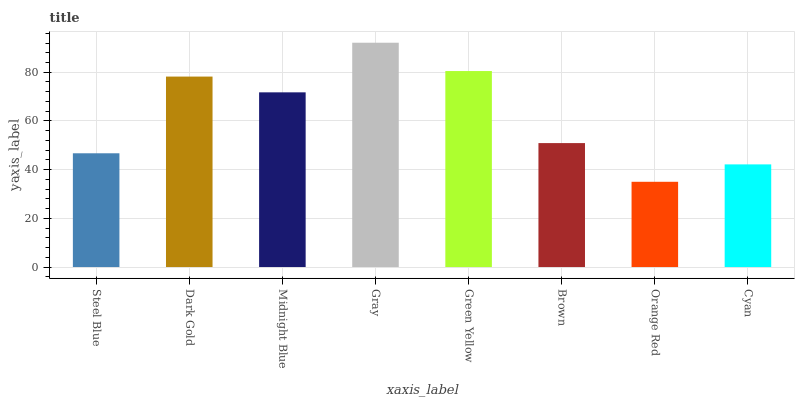Is Orange Red the minimum?
Answer yes or no. Yes. Is Gray the maximum?
Answer yes or no. Yes. Is Dark Gold the minimum?
Answer yes or no. No. Is Dark Gold the maximum?
Answer yes or no. No. Is Dark Gold greater than Steel Blue?
Answer yes or no. Yes. Is Steel Blue less than Dark Gold?
Answer yes or no. Yes. Is Steel Blue greater than Dark Gold?
Answer yes or no. No. Is Dark Gold less than Steel Blue?
Answer yes or no. No. Is Midnight Blue the high median?
Answer yes or no. Yes. Is Brown the low median?
Answer yes or no. Yes. Is Orange Red the high median?
Answer yes or no. No. Is Gray the low median?
Answer yes or no. No. 